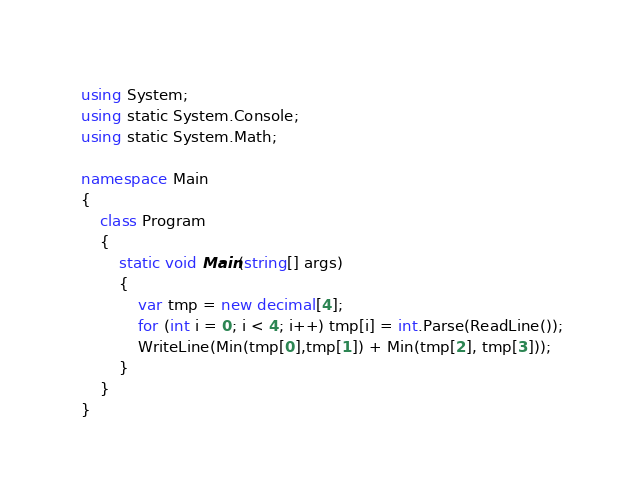<code> <loc_0><loc_0><loc_500><loc_500><_C#_>using System;
using static System.Console;
using static System.Math;

namespace Main
{
    class Program
    {
        static void Main(string[] args)
        {
            var tmp = new decimal[4];
            for (int i = 0; i < 4; i++) tmp[i] = int.Parse(ReadLine());
            WriteLine(Min(tmp[0],tmp[1]) + Min(tmp[2], tmp[3]));
        }
    }
}</code> 